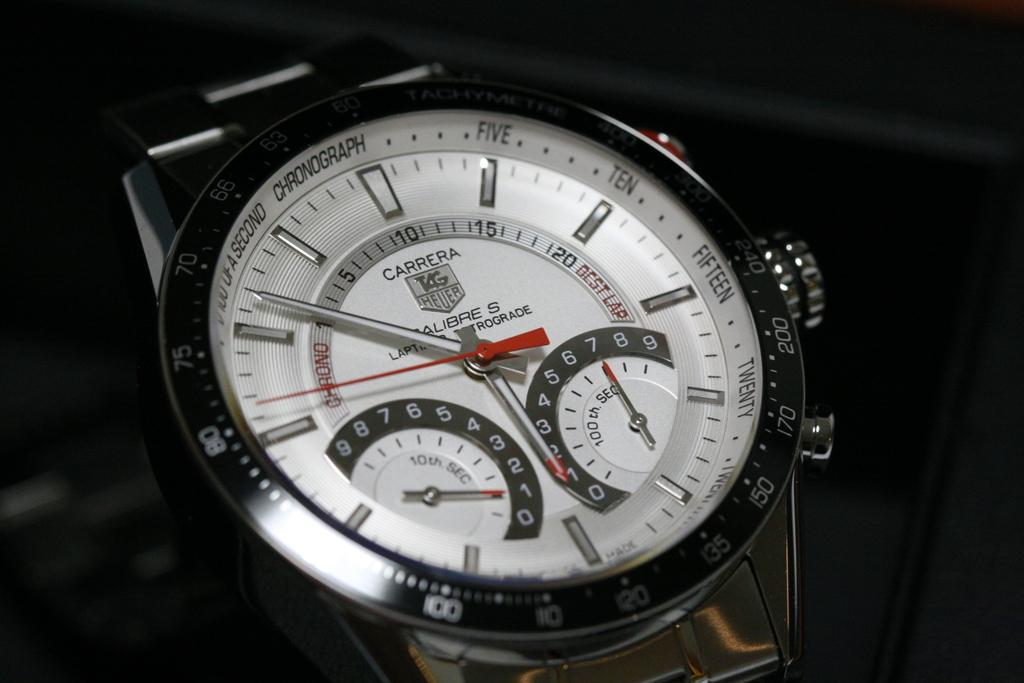<image>
Offer a succinct explanation of the picture presented. A back and white Carrera watch with a chronograph. 